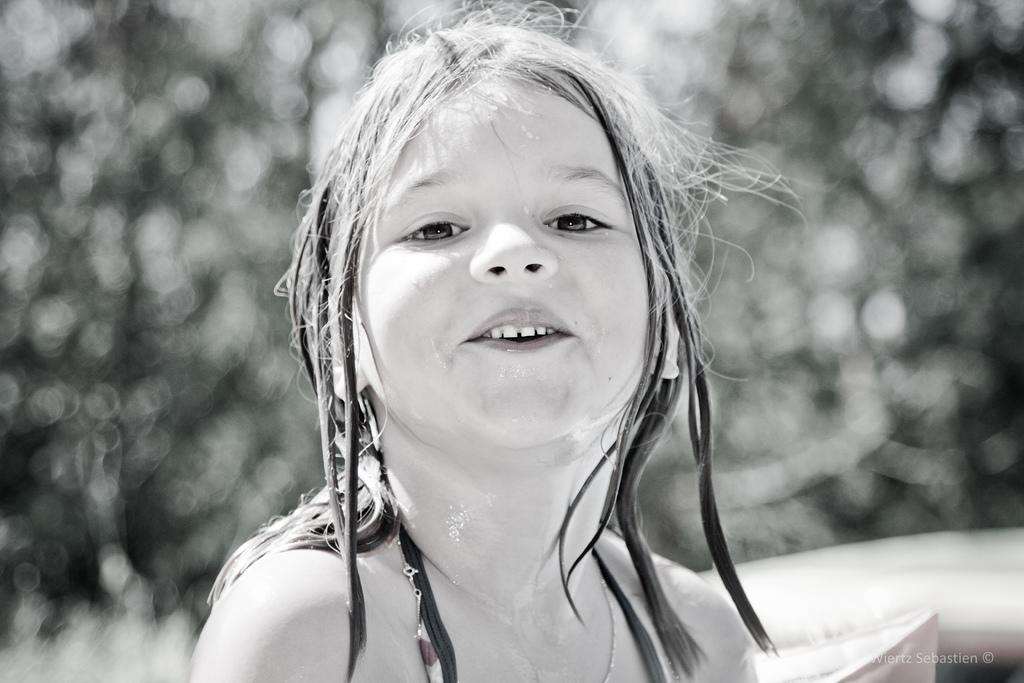Please provide a concise description of this image. In this picture I can see a girl and I can see water mark at the bottom right corner of the picture and I can see blurry background. 